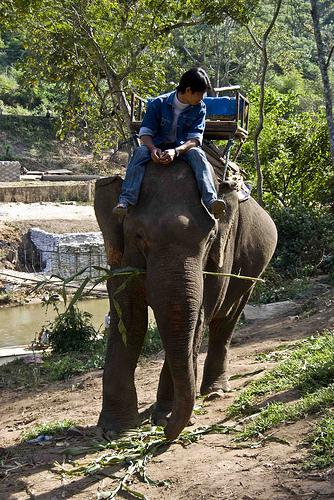Question: how many elephants?
Choices:
A. One.
B. Two.
C. Three.
D. Five.
Answer with the letter. Answer: A Question: what is the elephant doing?
Choices:
A. Sleeping.
B. Running.
C. Wading.
D. Eating.
Answer with the letter. Answer: D Question: who is on the chair?
Choices:
A. A boy.
B. Nobody.
C. A girl.
D. A cat.
Answer with the letter. Answer: B Question: what color is the elephant?
Choices:
A. Black.
B. Brown.
C. Gray.
D. White.
Answer with the letter. Answer: C Question: where is the water?
Choices:
A. In front of elephant.
B. Behind the elephant.
C. To left of elephant.
D. To right of elephant.
Answer with the letter. Answer: B 